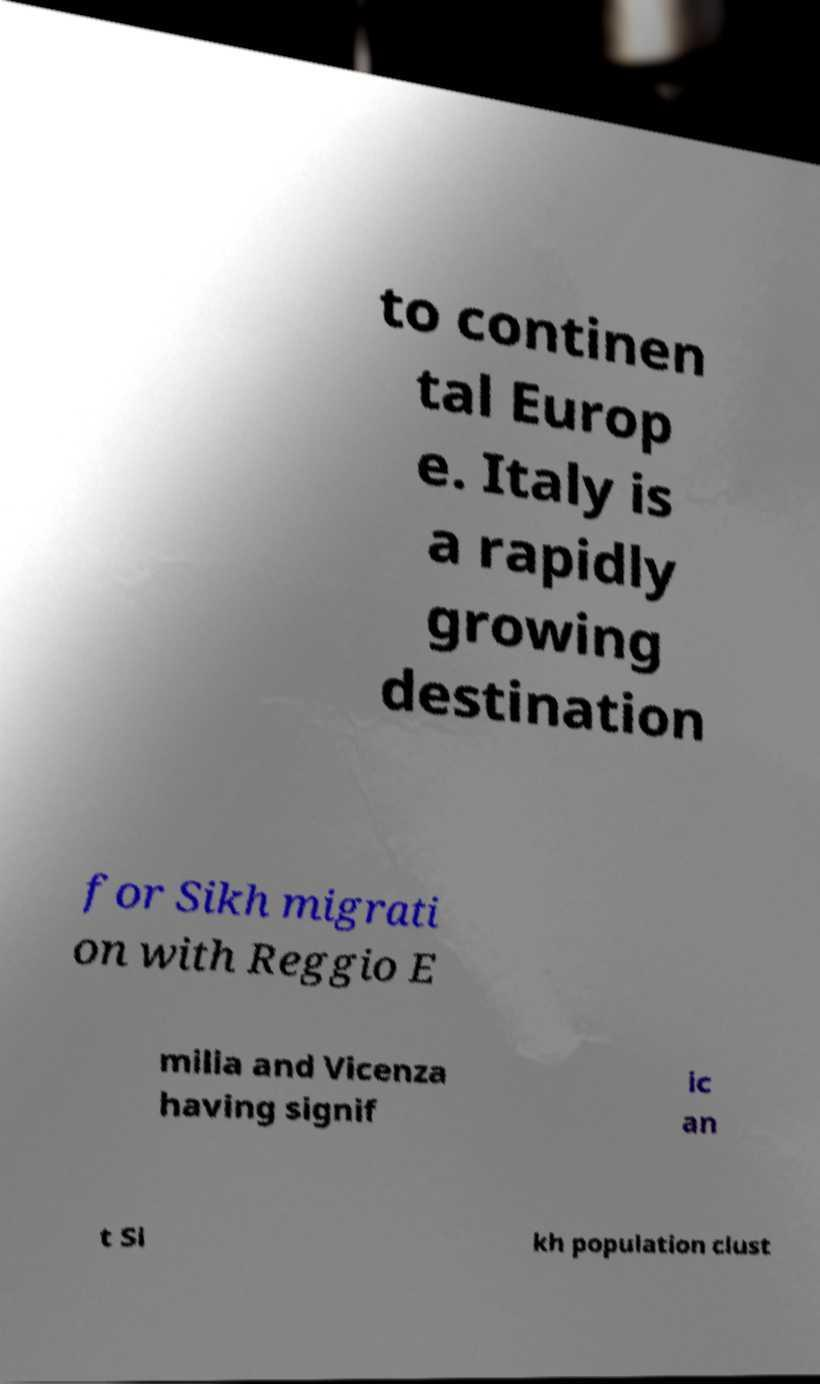Can you accurately transcribe the text from the provided image for me? to continen tal Europ e. Italy is a rapidly growing destination for Sikh migrati on with Reggio E milia and Vicenza having signif ic an t Si kh population clust 